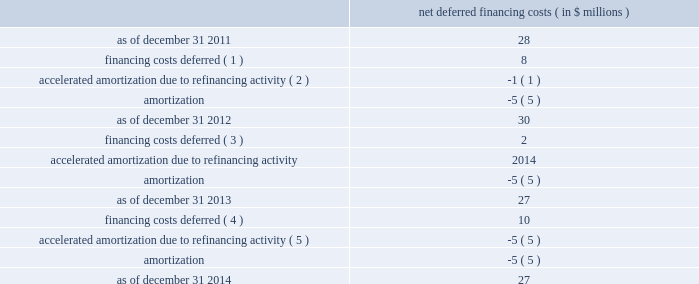Facility continue to have a maturity date of october 2016 .
In addition , the maturity date of the company's revolving credit facility was extended to october 2018 and the facility was increased to $ 900 million from $ 600 million .
Accordingly , the amended credit agreement consists of the term c-2 loan facility , the term c-3 loan facility and a $ 900 million revolving credit facility .
Net deferred financing costs are as follows : net deferred financing costs ( in $ millions ) .
____________________________ ( 1 ) relates to the issuance of the 4.625% ( 4.625 % ) notes .
( 2 ) relates to the $ 400 million prepayment of the term c loan facility with proceeds from the 4.625% ( 4.625 % ) notes .
( 3 ) relates to the september 2013 amendment to the celanese us existing senior secured credit facilities to reduce the interest rates payable in connection with certain borrowings thereby creating the term c-2 loan facility due 2016 .
( 4 ) includes $ 6 million related to the issuance of the 3.250% ( 3.250 % ) notes and $ 4 million related to the september 24 , 2014 amendment to the celanese us existing senior secured credit facilities .
( 5 ) includes $ 4 million related to the 6.625% ( 6.625 % ) notes redemption and $ 1 million related to the term c-2 loan facility conversion .
As of december 31 , 2014 , the margin for borrowings under the term c-2 loan facility was 2.0% ( 2.0 % ) above the euro interbank offered rate ( "euribor" ) and the margin for borrowings under the term c-3 loan facility was 2.25% ( 2.25 % ) above libor ( for us dollars ) and 2.25% ( 2.25 % ) above euribor ( for euros ) , as applicable .
As of december 31 , 2014 , the margin for borrowings under the revolving credit facility was 1.5% ( 1.5 % ) above libor .
The margin for borrowings under the revolving credit facility is subject to increase or decrease in certain circumstances based on changes in the corporate credit ratings of celanese or celanese us .
Term loan borrowings under the amended credit agreement are subject to amortization at 1% ( 1 % ) of the initial principal amount per annum , payable quarterly .
In addition , the company pays quarterly commitment fees on the unused portion of the revolving credit facility of 0.25% ( 0.25 % ) per annum .
The amended credit agreement is guaranteed by celanese and certain domestic subsidiaries of celanese us and is secured by a lien on substantially all assets of celanese us and such guarantors , subject to certain agreed exceptions ( including for certain real property and certain shares of foreign subsidiaries ) , pursuant to the guarantee and collateral agreement , dated april 2 , as a condition to borrowing funds or requesting letters of credit be issued under the revolving credit facility , the company's first lien senior secured leverage ratio ( as calculated as of the last day of the most recent fiscal quarter for which financial statements have been delivered under the revolving facility ) cannot exceed the threshold as specified below .
Further , the company's first lien senior secured leverage ratio must be maintained at or below that threshold while any amounts are outstanding under the revolving credit facility. .
How much of the 2013 amortization expense is due to the term c-2 loan facility conversion? 
Computations: (1 / 5)
Answer: 0.2. Facility continue to have a maturity date of october 2016 .
In addition , the maturity date of the company's revolving credit facility was extended to october 2018 and the facility was increased to $ 900 million from $ 600 million .
Accordingly , the amended credit agreement consists of the term c-2 loan facility , the term c-3 loan facility and a $ 900 million revolving credit facility .
Net deferred financing costs are as follows : net deferred financing costs ( in $ millions ) .
____________________________ ( 1 ) relates to the issuance of the 4.625% ( 4.625 % ) notes .
( 2 ) relates to the $ 400 million prepayment of the term c loan facility with proceeds from the 4.625% ( 4.625 % ) notes .
( 3 ) relates to the september 2013 amendment to the celanese us existing senior secured credit facilities to reduce the interest rates payable in connection with certain borrowings thereby creating the term c-2 loan facility due 2016 .
( 4 ) includes $ 6 million related to the issuance of the 3.250% ( 3.250 % ) notes and $ 4 million related to the september 24 , 2014 amendment to the celanese us existing senior secured credit facilities .
( 5 ) includes $ 4 million related to the 6.625% ( 6.625 % ) notes redemption and $ 1 million related to the term c-2 loan facility conversion .
As of december 31 , 2014 , the margin for borrowings under the term c-2 loan facility was 2.0% ( 2.0 % ) above the euro interbank offered rate ( "euribor" ) and the margin for borrowings under the term c-3 loan facility was 2.25% ( 2.25 % ) above libor ( for us dollars ) and 2.25% ( 2.25 % ) above euribor ( for euros ) , as applicable .
As of december 31 , 2014 , the margin for borrowings under the revolving credit facility was 1.5% ( 1.5 % ) above libor .
The margin for borrowings under the revolving credit facility is subject to increase or decrease in certain circumstances based on changes in the corporate credit ratings of celanese or celanese us .
Term loan borrowings under the amended credit agreement are subject to amortization at 1% ( 1 % ) of the initial principal amount per annum , payable quarterly .
In addition , the company pays quarterly commitment fees on the unused portion of the revolving credit facility of 0.25% ( 0.25 % ) per annum .
The amended credit agreement is guaranteed by celanese and certain domestic subsidiaries of celanese us and is secured by a lien on substantially all assets of celanese us and such guarantors , subject to certain agreed exceptions ( including for certain real property and certain shares of foreign subsidiaries ) , pursuant to the guarantee and collateral agreement , dated april 2 , as a condition to borrowing funds or requesting letters of credit be issued under the revolving credit facility , the company's first lien senior secured leverage ratio ( as calculated as of the last day of the most recent fiscal quarter for which financial statements have been delivered under the revolving facility ) cannot exceed the threshold as specified below .
Further , the company's first lien senior secured leverage ratio must be maintained at or below that threshold while any amounts are outstanding under the revolving credit facility. .
Assuming the revolver is undrawn , what would the annual fee for the revolver be? 
Computations: ((900 * 0.25%) * 1000000)
Answer: 2250000.0. 